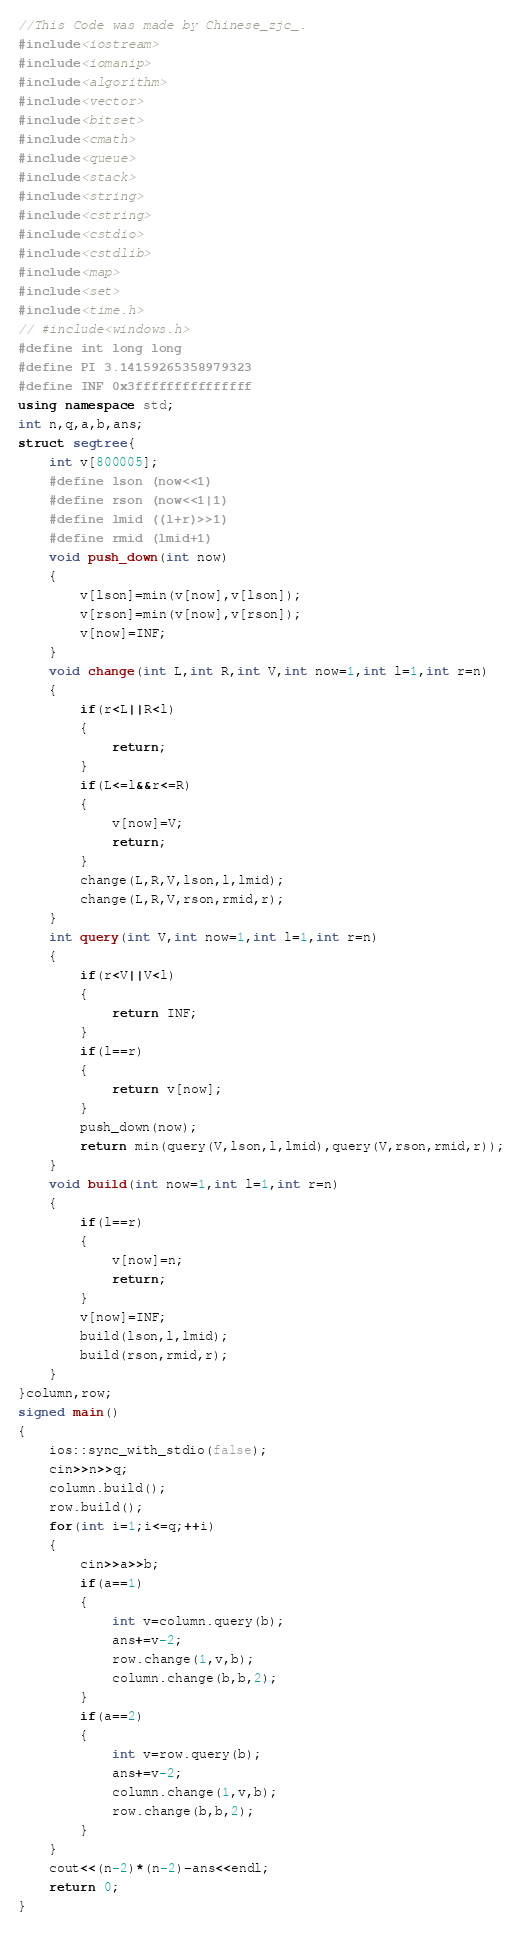<code> <loc_0><loc_0><loc_500><loc_500><_C++_>//This Code was made by Chinese_zjc_.
#include<iostream>
#include<iomanip>
#include<algorithm>
#include<vector>
#include<bitset>
#include<cmath>
#include<queue>
#include<stack>
#include<string>
#include<cstring>
#include<cstdio>
#include<cstdlib>
#include<map>
#include<set>
#include<time.h>
// #include<windows.h>
#define int long long
#define PI 3.14159265358979323
#define INF 0x3fffffffffffffff
using namespace std;
int n,q,a,b,ans;
struct segtree{
    int v[800005];
    #define lson (now<<1)
    #define rson (now<<1|1)
    #define lmid ((l+r)>>1)
    #define rmid (lmid+1)
    void push_down(int now)
    {
        v[lson]=min(v[now],v[lson]);
        v[rson]=min(v[now],v[rson]);
        v[now]=INF;
    }
    void change(int L,int R,int V,int now=1,int l=1,int r=n)
    {
        if(r<L||R<l)
        {
            return;
        }
        if(L<=l&&r<=R)
        {
            v[now]=V;
            return;
        }
        change(L,R,V,lson,l,lmid);
        change(L,R,V,rson,rmid,r);
    }
    int query(int V,int now=1,int l=1,int r=n)
    {
        if(r<V||V<l)
        {
            return INF;
        }
        if(l==r)
        {
            return v[now];
        }
        push_down(now);
        return min(query(V,lson,l,lmid),query(V,rson,rmid,r));
    }
    void build(int now=1,int l=1,int r=n)
    {
        if(l==r)
        {
            v[now]=n;
            return;
        }
        v[now]=INF;
        build(lson,l,lmid);
        build(rson,rmid,r);
    }
}column,row;
signed main()
{
    ios::sync_with_stdio(false);
    cin>>n>>q;
    column.build();
    row.build();
    for(int i=1;i<=q;++i)
    {
        cin>>a>>b;
        if(a==1)
        {
            int v=column.query(b);
            ans+=v-2;
            row.change(1,v,b);
            column.change(b,b,2);
        }
        if(a==2)
        {
            int v=row.query(b);
            ans+=v-2;
            column.change(1,v,b);
            row.change(b,b,2);
        }
    }
    cout<<(n-2)*(n-2)-ans<<endl;
    return 0;
}</code> 